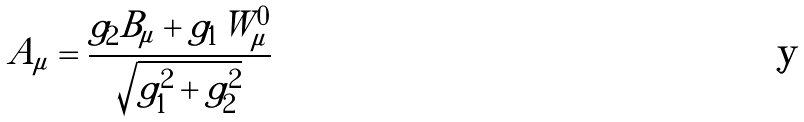<formula> <loc_0><loc_0><loc_500><loc_500>A _ { \mu } = \frac { g _ { 2 } B _ { \mu } + g _ { 1 } W _ { \mu } ^ { 0 } } { \sqrt { g _ { 1 } ^ { 2 } + g _ { 2 } ^ { 2 } } }</formula> 